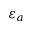Convert formula to latex. <formula><loc_0><loc_0><loc_500><loc_500>\varepsilon _ { a }</formula> 